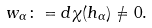Convert formula to latex. <formula><loc_0><loc_0><loc_500><loc_500>w _ { \alpha } \colon = d \chi ( h _ { \alpha } ) \neq 0 .</formula> 